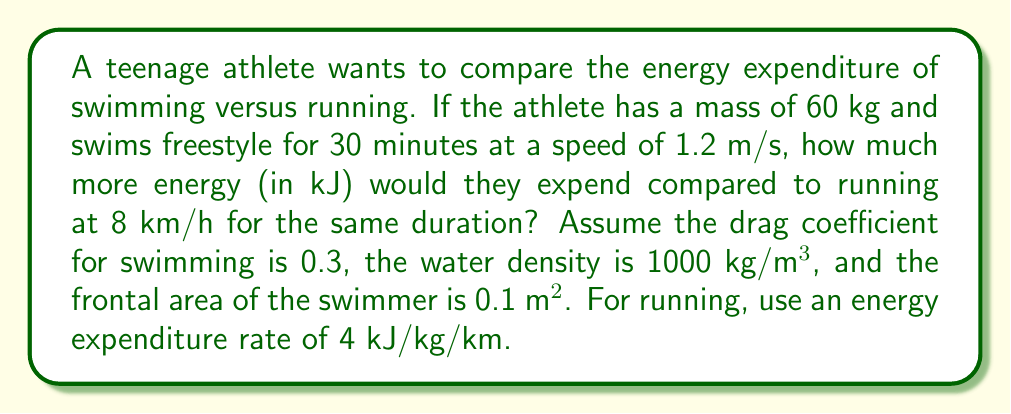Show me your answer to this math problem. To solve this problem, we need to calculate the energy expended during swimming and running separately, then compare them.

1. Swimming energy expenditure:
   The power required to overcome drag while swimming is given by:
   $$P = \frac{1}{2} \cdot C_d \cdot \rho \cdot A \cdot v^3$$
   Where:
   $C_d$ = drag coefficient = 0.3
   $\rho$ = water density = 1000 kg/m³
   $A$ = frontal area = 0.1 m²
   $v$ = velocity = 1.2 m/s

   Plugging in the values:
   $$P = \frac{1}{2} \cdot 0.3 \cdot 1000 \cdot 0.1 \cdot 1.2^3 = 25.92 \text{ W}$$

   Energy expended = Power × Time
   $$E_{\text{swimming}} = 25.92 \text{ W} \cdot (30 \cdot 60) \text{ s} = 46,656 \text{ J} = 46.656 \text{ kJ}$$

2. Running energy expenditure:
   Given rate: 4 kJ/kg/km
   Distance covered in 30 minutes at 8 km/h:
   $$d = 8 \text{ km/h} \cdot 0.5 \text{ h} = 4 \text{ km}$$

   Energy expended:
   $$E_{\text{running}} = 60 \text{ kg} \cdot 4 \text{ km} \cdot 4 \text{ kJ/kg/km} = 960 \text{ kJ}$$

3. Difference in energy expenditure:
   $$\Delta E = E_{\text{running}} - E_{\text{swimming}} = 960 \text{ kJ} - 46.656 \text{ kJ} = 913.344 \text{ kJ}$$

Therefore, the athlete would expend 913.344 kJ more energy running than swimming for the same duration.
Answer: 913.344 kJ 